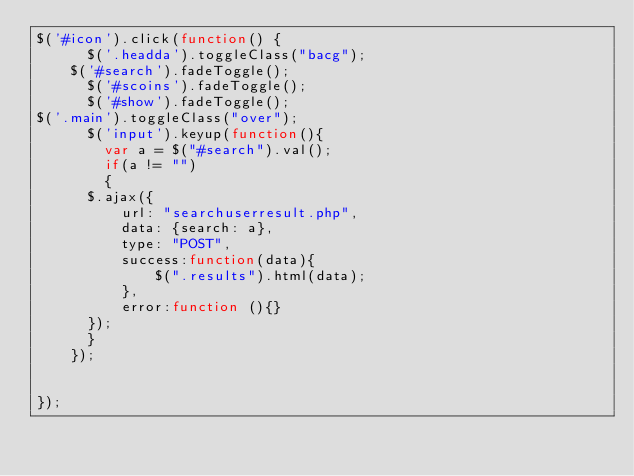Convert code to text. <code><loc_0><loc_0><loc_500><loc_500><_JavaScript_>$('#icon').click(function() {
      $('.headda').toggleClass("bacg");
    $('#search').fadeToggle();
      $('#scoins').fadeToggle();
      $('#show').fadeToggle();
$('.main').toggleClass("over");
      $('input').keyup(function(){
        var a = $("#search").val();
        if(a != "")
        {
      $.ajax({
          url: "searchuserresult.php",
          data: {search: a},
          type: "POST",
          success:function(data){
              $(".results").html(data);
          },
          error:function (){}
      });
      }
    });


});
</code> 